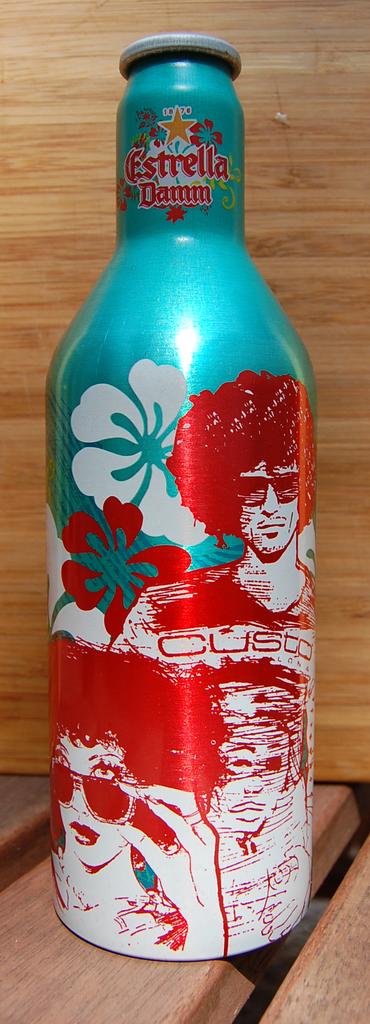What is the brand of this beverage?
Provide a short and direct response. Estrella damm. Does it say custo on the bottle?
Give a very brief answer. Yes. 